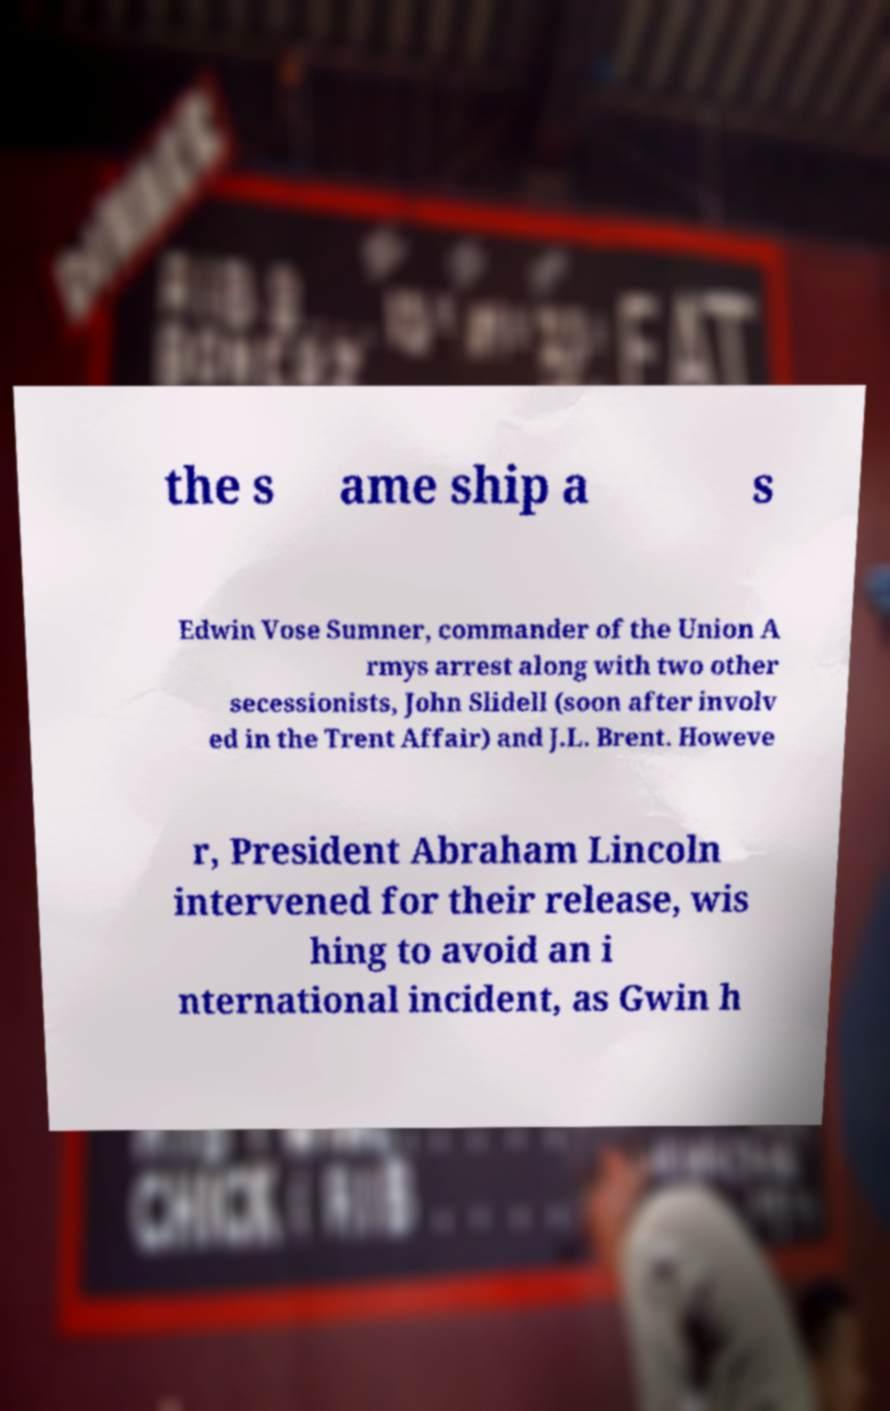What messages or text are displayed in this image? I need them in a readable, typed format. the s ame ship a s Edwin Vose Sumner, commander of the Union A rmys arrest along with two other secessionists, John Slidell (soon after involv ed in the Trent Affair) and J.L. Brent. Howeve r, President Abraham Lincoln intervened for their release, wis hing to avoid an i nternational incident, as Gwin h 